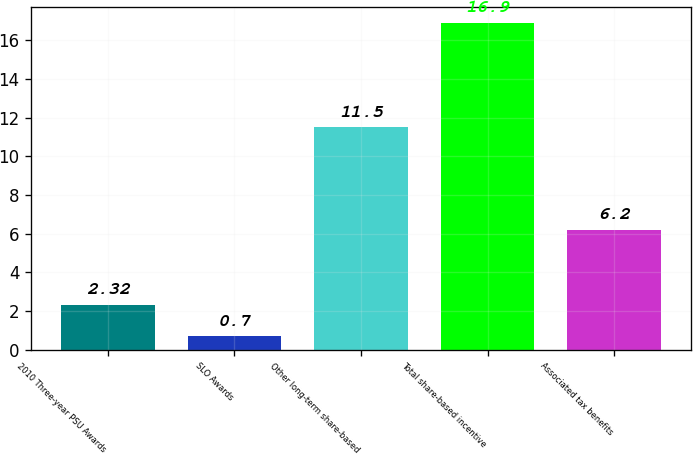Convert chart to OTSL. <chart><loc_0><loc_0><loc_500><loc_500><bar_chart><fcel>2010 Three-year PSU Awards<fcel>SLO Awards<fcel>Other long-term share-based<fcel>Total share-based incentive<fcel>Associated tax benefits<nl><fcel>2.32<fcel>0.7<fcel>11.5<fcel>16.9<fcel>6.2<nl></chart> 